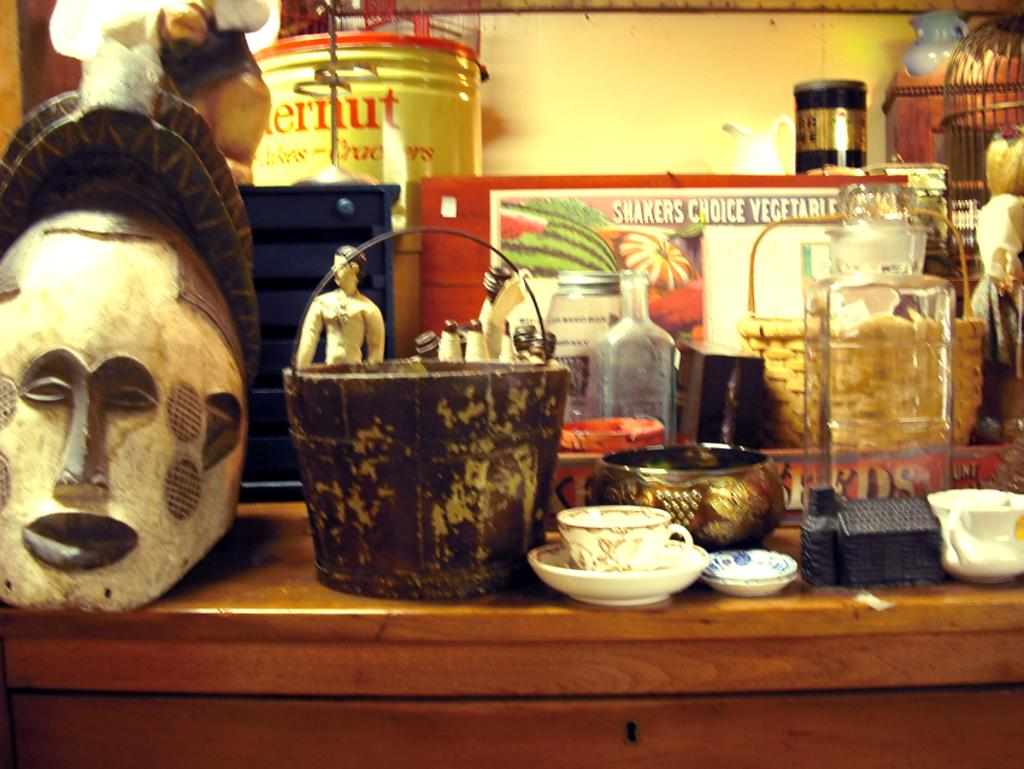What piece of furniture is present in the image? There is a table in the image. What items can be seen on the table? There are cups, saucers, bottles, baskets, a mask, a hoarding, and other objects on the table. Can you describe the cups and saucers on the table? The cups and saucers are likely used for serving beverages. What might the bottles on the table contain? The bottles on the table might contain liquids, such as water or juice. How does the toe affect the market in the image? There is no mention of a toe or a market in the image, so it is not possible to answer this question. 